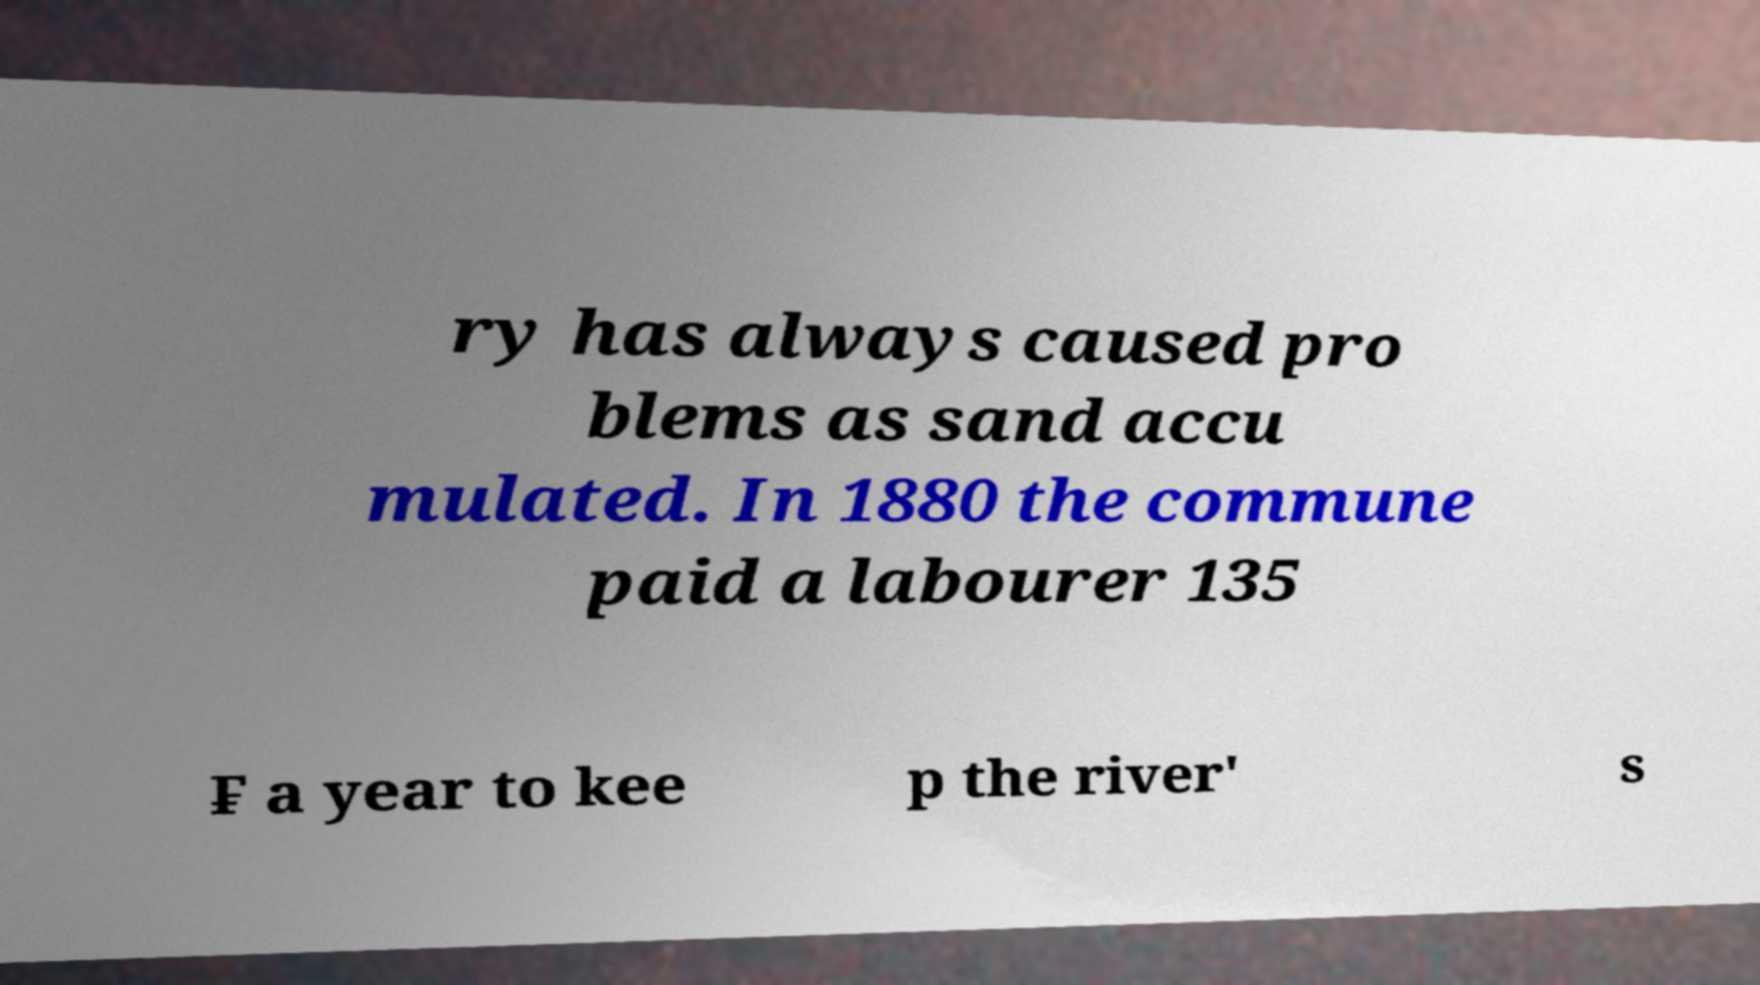There's text embedded in this image that I need extracted. Can you transcribe it verbatim? ry has always caused pro blems as sand accu mulated. In 1880 the commune paid a labourer 135 ₣ a year to kee p the river' s 